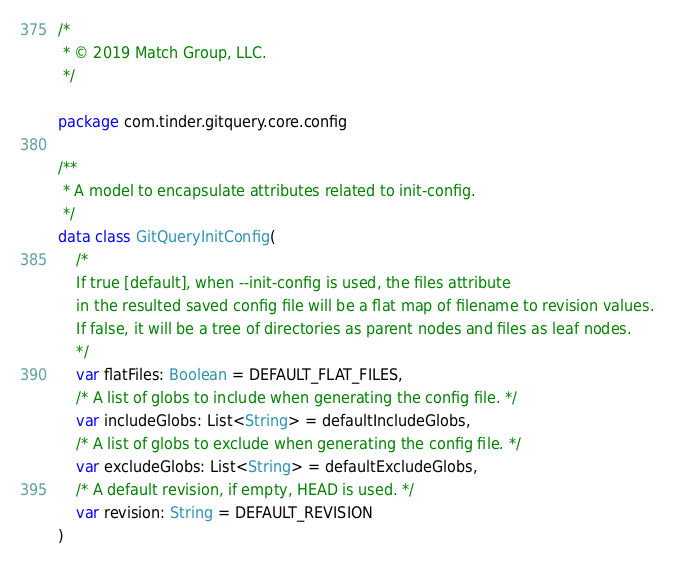Convert code to text. <code><loc_0><loc_0><loc_500><loc_500><_Kotlin_>/*
 * © 2019 Match Group, LLC.
 */

package com.tinder.gitquery.core.config

/**
 * A model to encapsulate attributes related to init-config.
 */
data class GitQueryInitConfig(
    /*
    If true [default], when --init-config is used, the files attribute
    in the resulted saved config file will be a flat map of filename to revision values.
    If false, it will be a tree of directories as parent nodes and files as leaf nodes.
    */
    var flatFiles: Boolean = DEFAULT_FLAT_FILES,
    /* A list of globs to include when generating the config file. */
    var includeGlobs: List<String> = defaultIncludeGlobs,
    /* A list of globs to exclude when generating the config file. */
    var excludeGlobs: List<String> = defaultExcludeGlobs,
    /* A default revision, if empty, HEAD is used. */
    var revision: String = DEFAULT_REVISION
)
</code> 